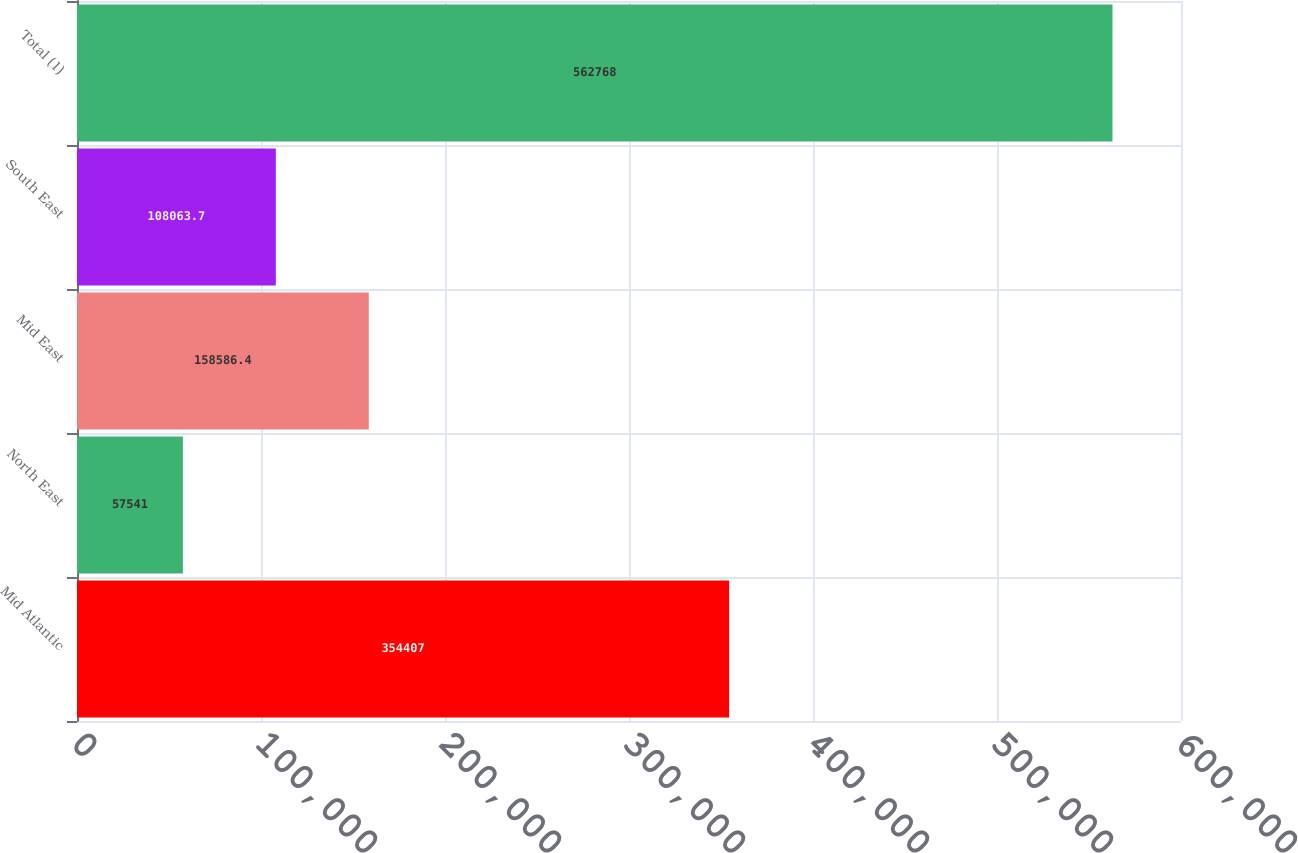<chart> <loc_0><loc_0><loc_500><loc_500><bar_chart><fcel>Mid Atlantic<fcel>North East<fcel>Mid East<fcel>South East<fcel>Total (1)<nl><fcel>354407<fcel>57541<fcel>158586<fcel>108064<fcel>562768<nl></chart> 